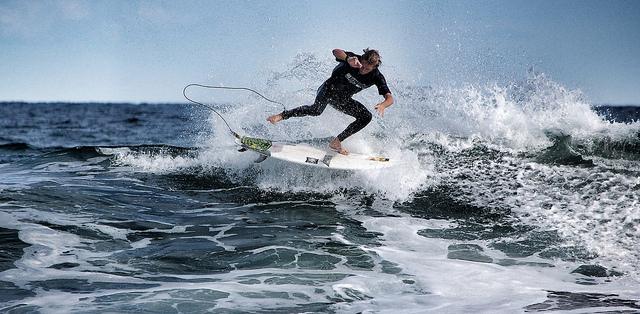Is this person riding a jet ski?
Quick response, please. No. What is the white stuff on the water?
Quick response, please. Foam. Is the person falling into the water?
Answer briefly. Yes. 